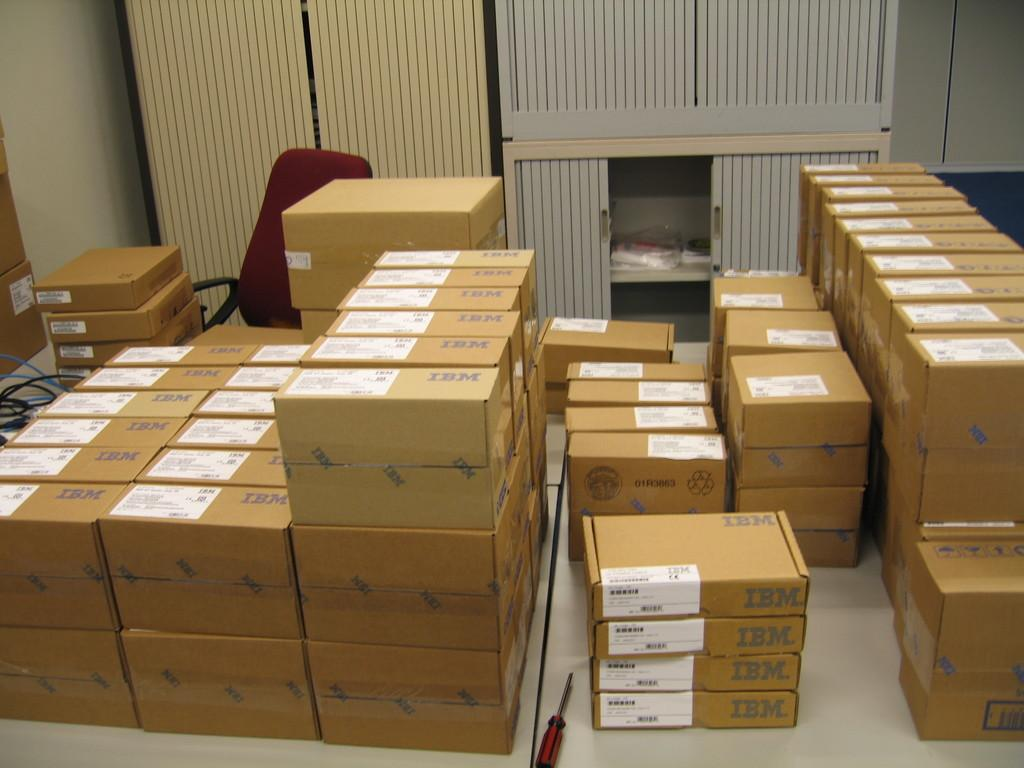<image>
Write a terse but informative summary of the picture. many sealed card board boxes with IBM on them 